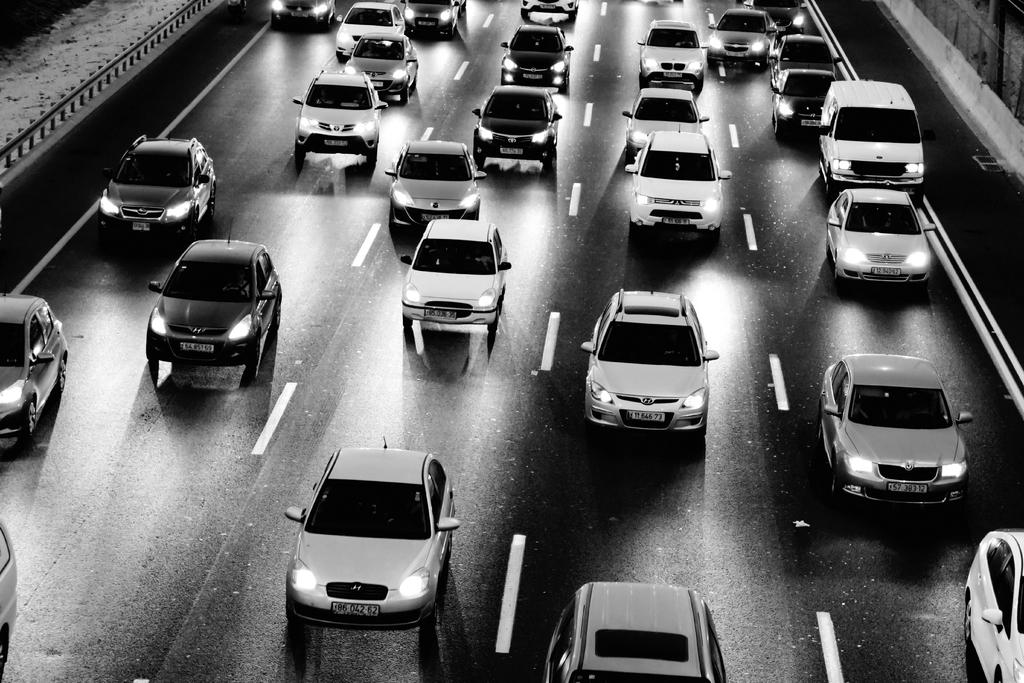What type of vehicles can be seen parked on the road in the image? There are cars parked on the road in the image. Can you describe the color scheme of the image? The image is in black and white color. Where is the toothpaste being used in the image? There is no toothpaste present in the image. What type of office equipment can be seen in the image? There is no office equipment present in the image. How many potatoes are visible in the image? There are no potatoes present in the image. 